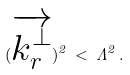<formula> <loc_0><loc_0><loc_500><loc_500>( \overrightarrow { k _ { r } ^ { \perp } } ) ^ { 2 } \, < \, \Lambda ^ { 2 } \, .</formula> 